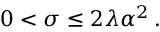Convert formula to latex. <formula><loc_0><loc_0><loc_500><loc_500>0 < \sigma \leq 2 \lambda \alpha ^ { 2 } \, .</formula> 